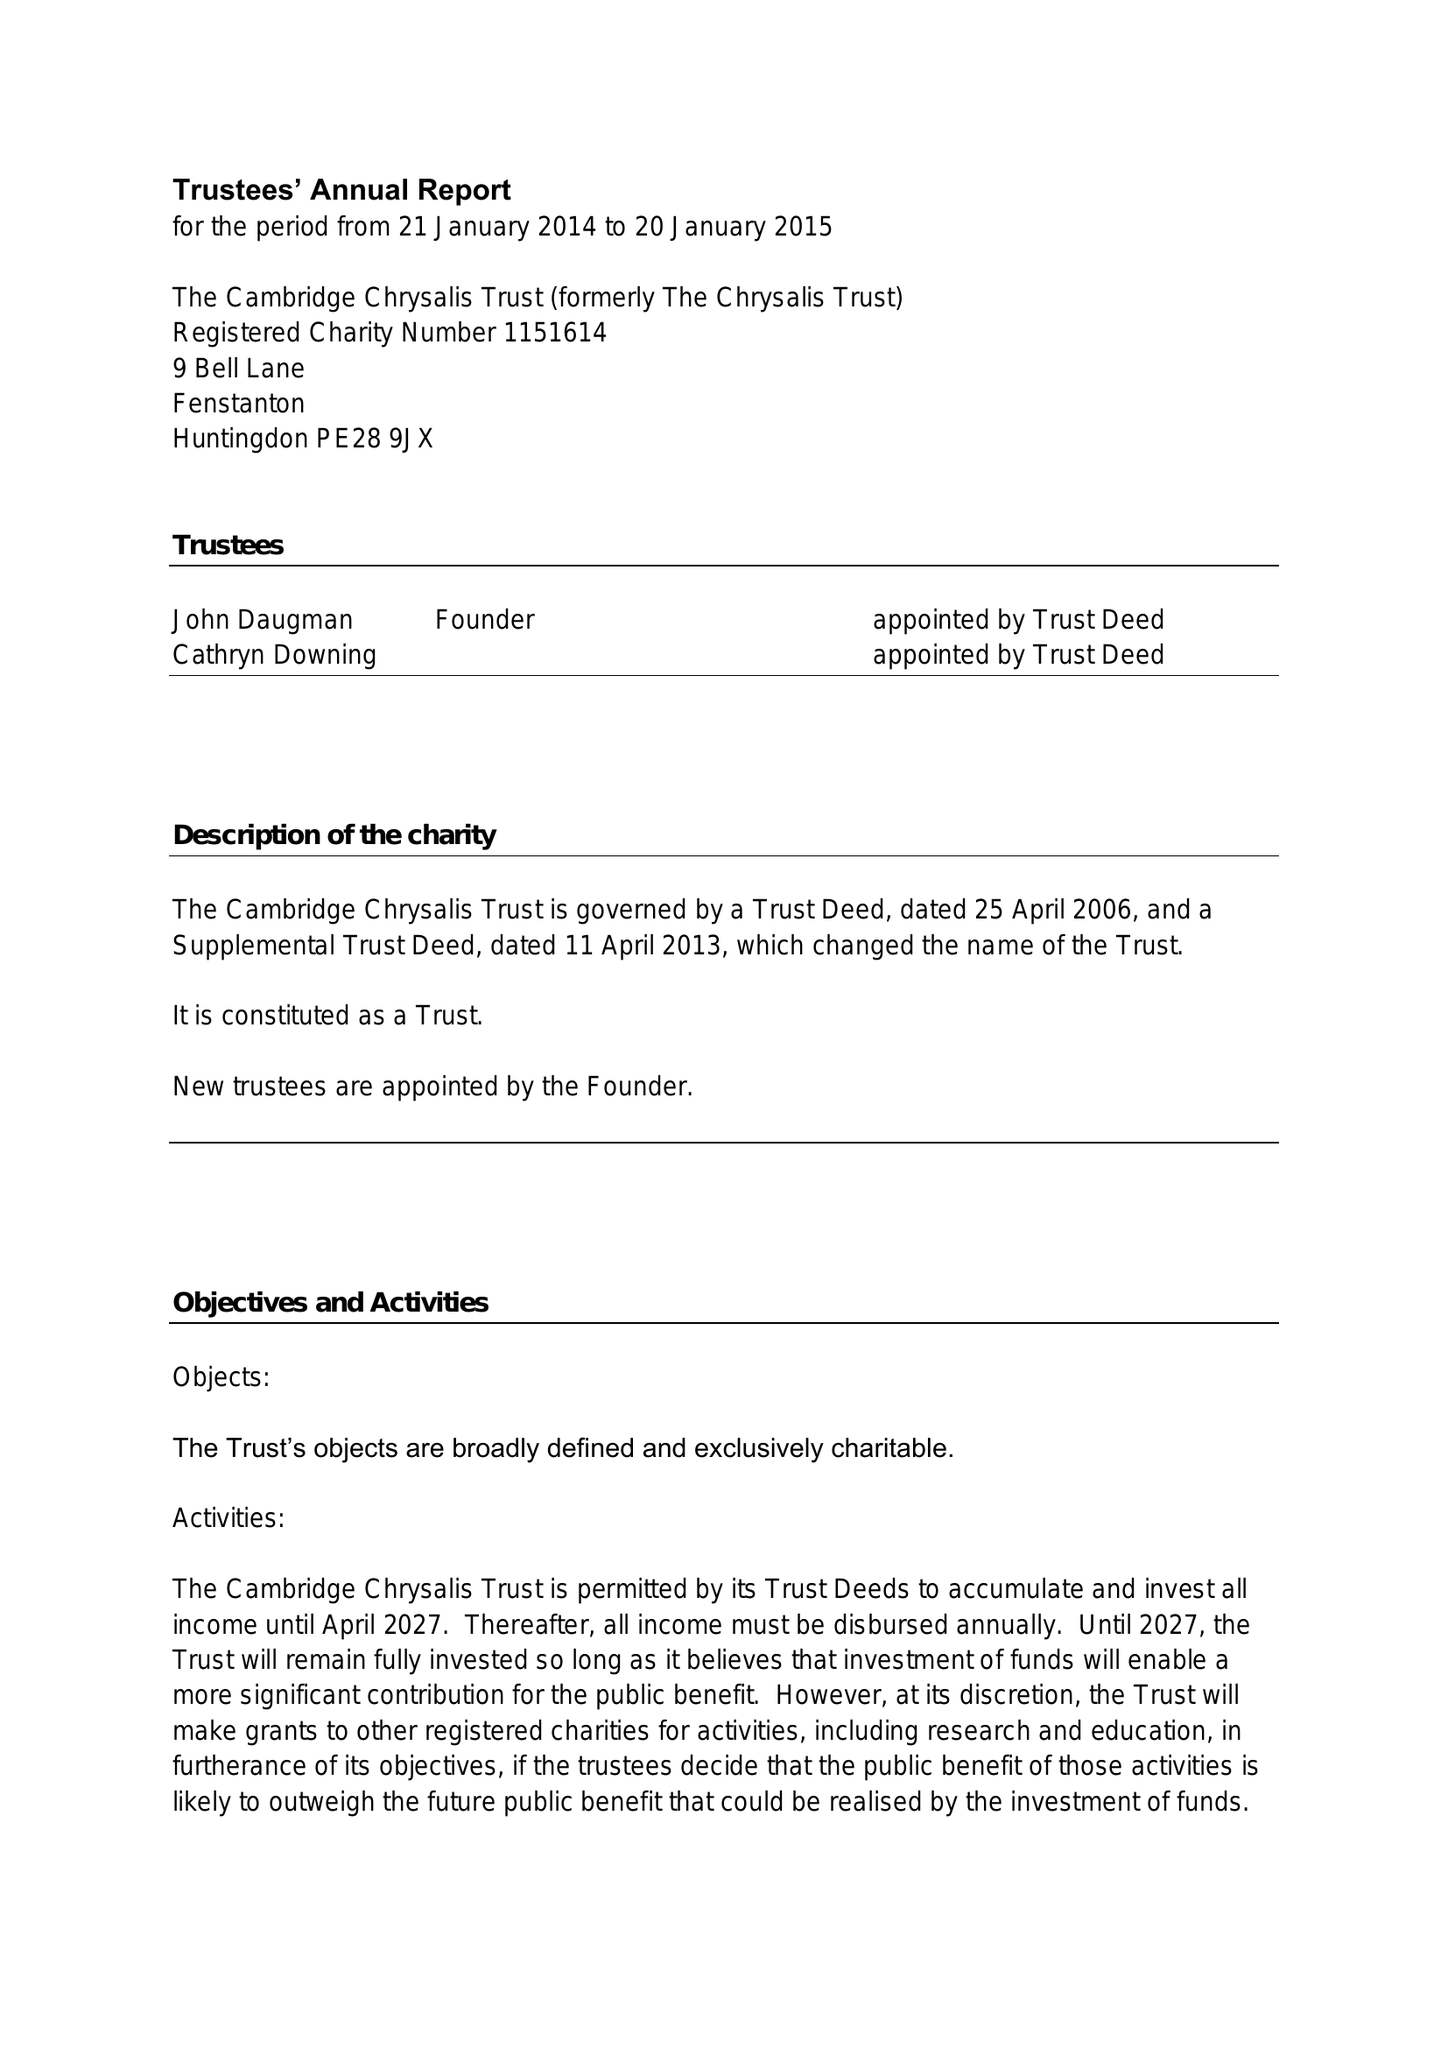What is the value for the spending_annually_in_british_pounds?
Answer the question using a single word or phrase. 34507.00 